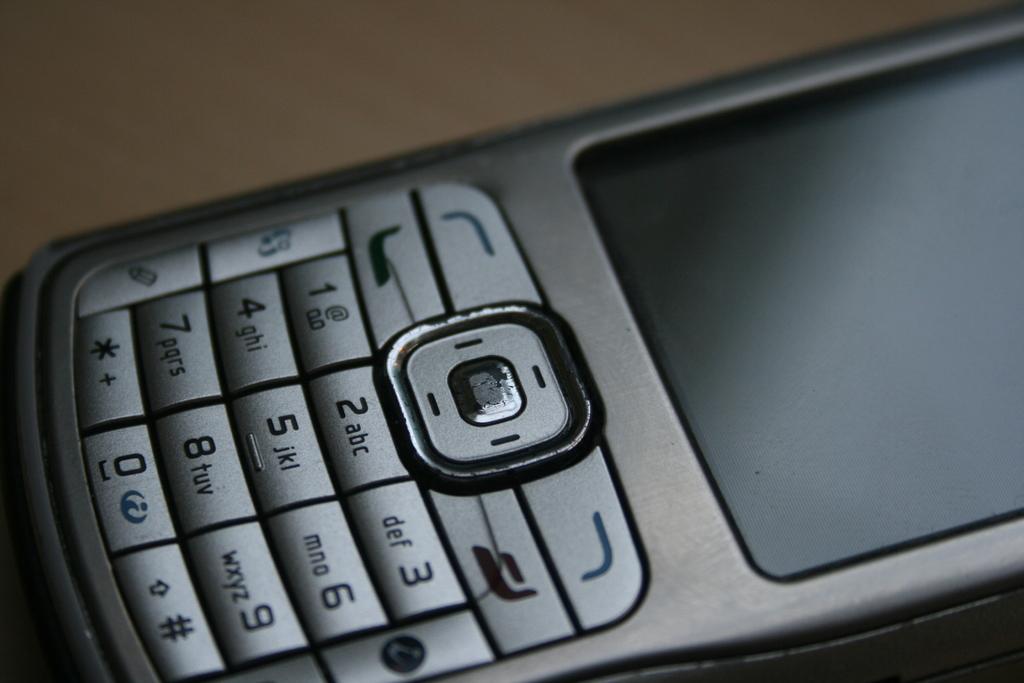What letters are next to the number 3?
Your response must be concise. Def. 